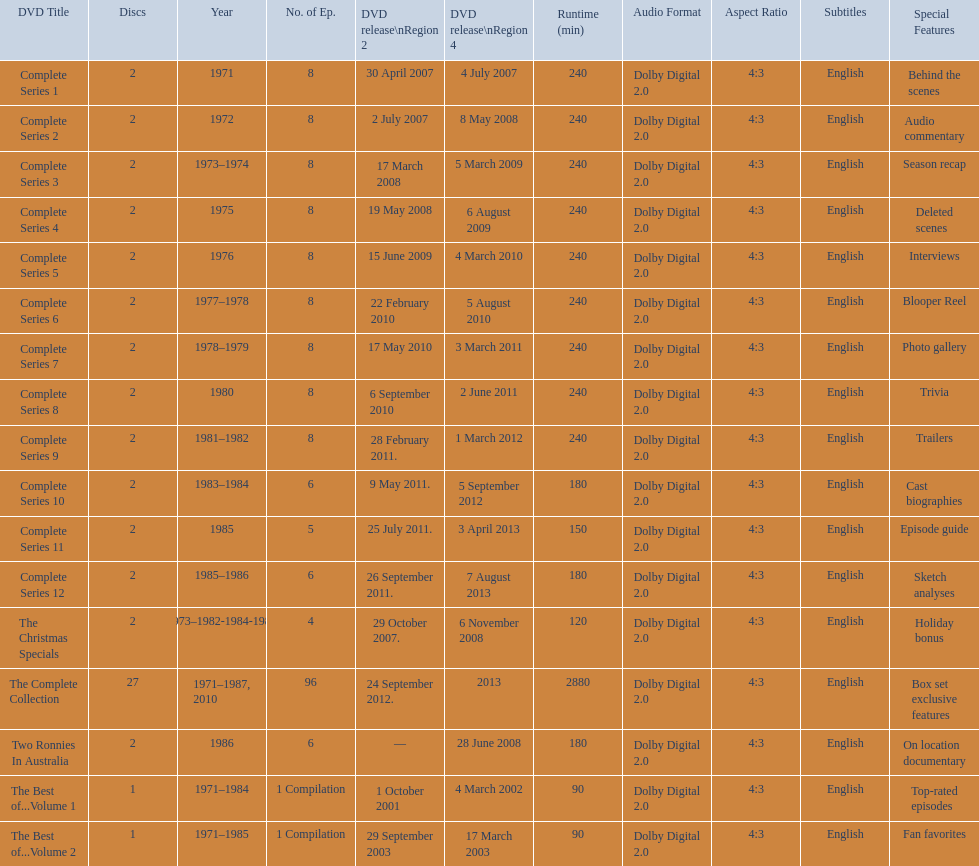What is the total of all dics listed in the table? 57. 